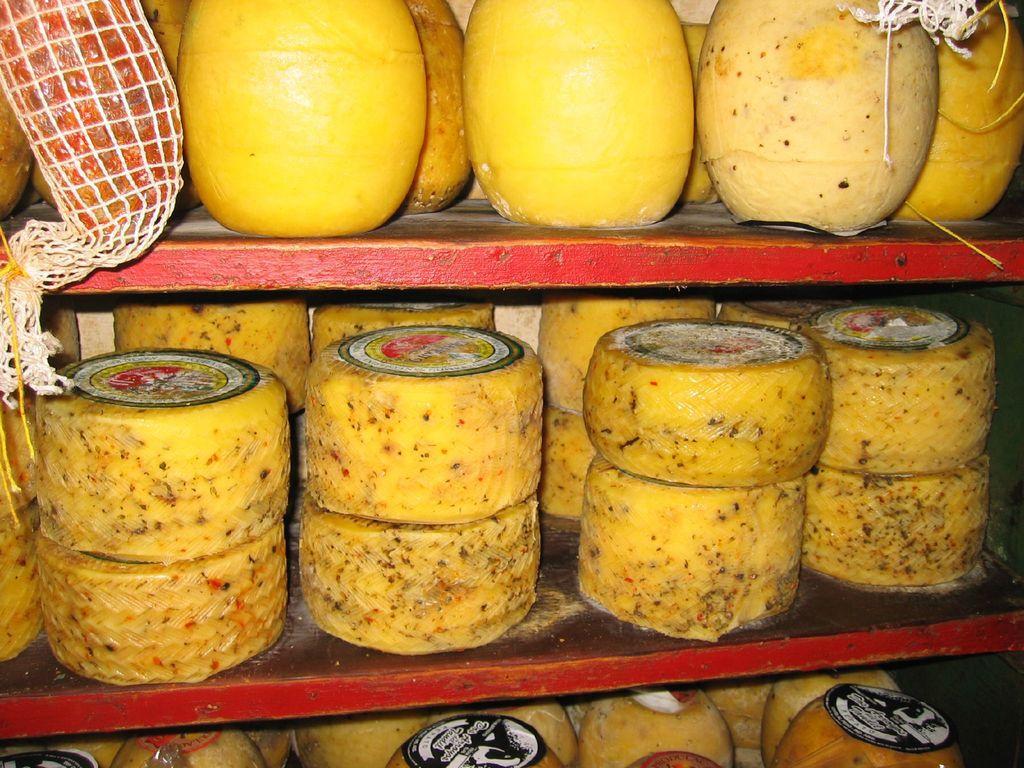Describe this image in one or two sentences. In this picture I can see cheese blocks with stickers, in a shelf. 